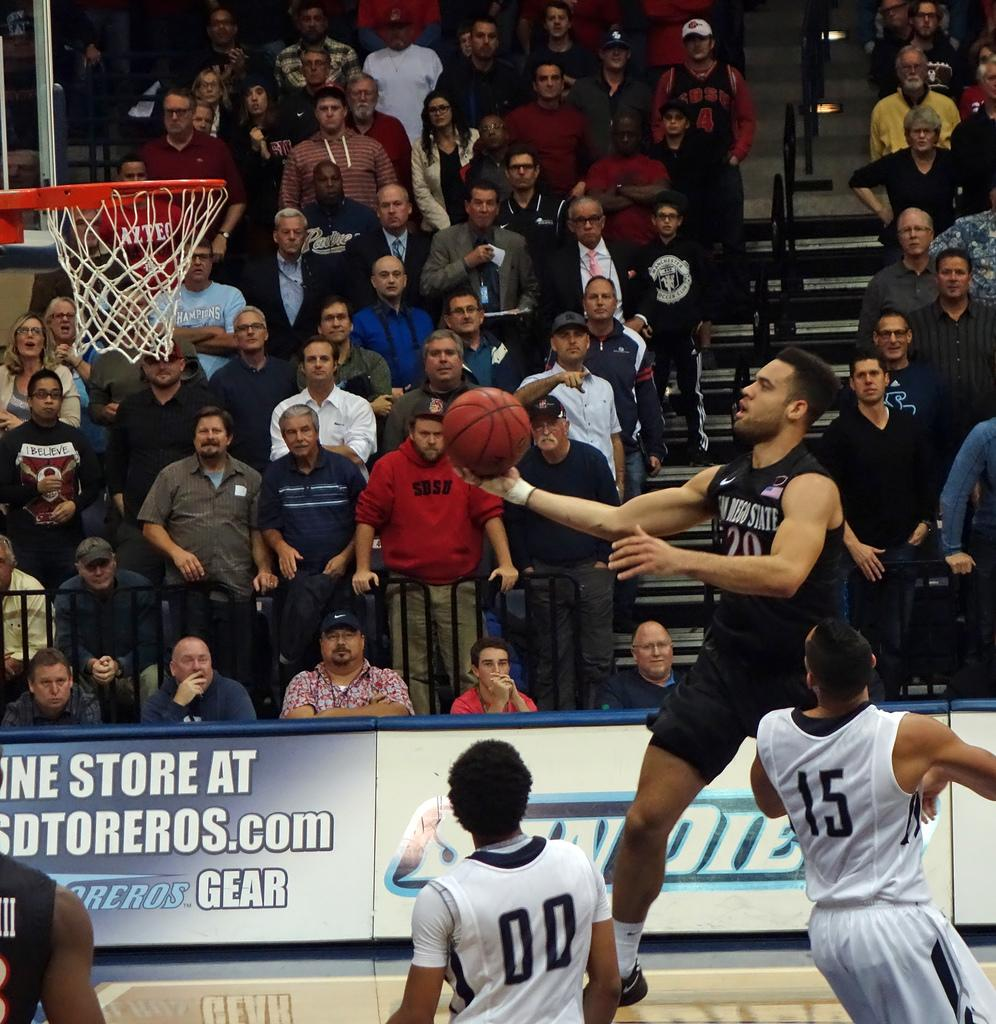<image>
Render a clear and concise summary of the photo. A hoops player from San Diego State leaps toward the basket, readying for a dunk. 